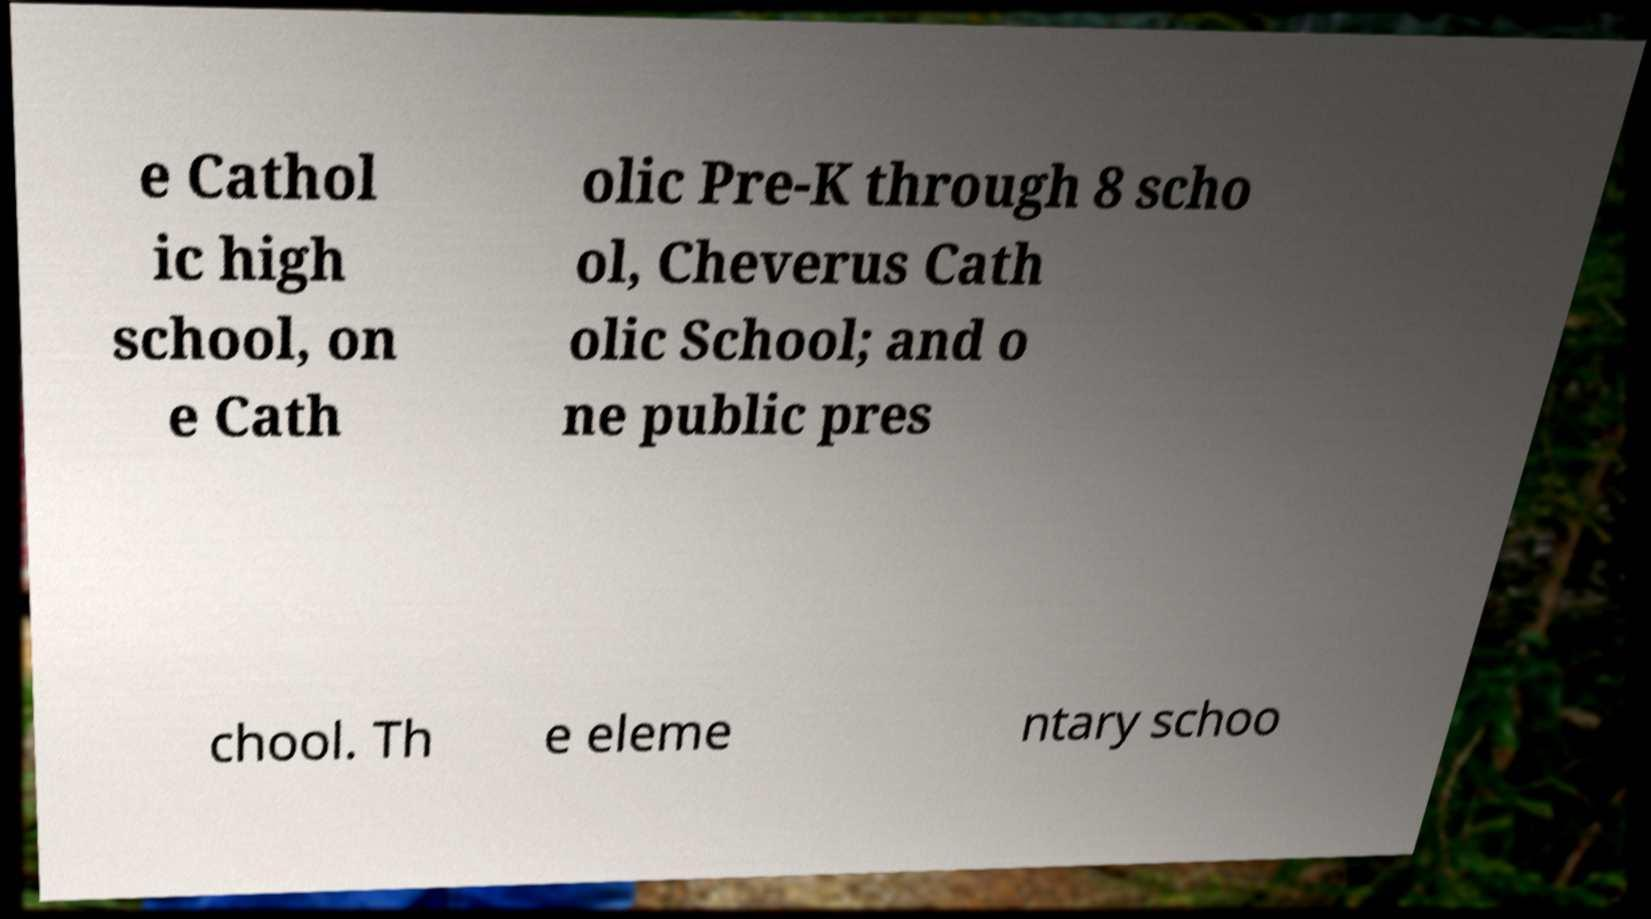Can you read and provide the text displayed in the image?This photo seems to have some interesting text. Can you extract and type it out for me? e Cathol ic high school, on e Cath olic Pre-K through 8 scho ol, Cheverus Cath olic School; and o ne public pres chool. Th e eleme ntary schoo 